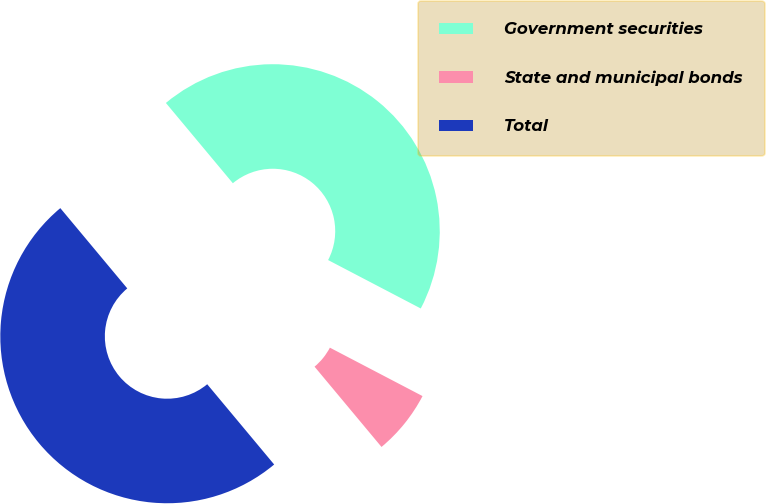Convert chart. <chart><loc_0><loc_0><loc_500><loc_500><pie_chart><fcel>Government securities<fcel>State and municipal bonds<fcel>Total<nl><fcel>43.73%<fcel>6.27%<fcel>50.0%<nl></chart> 